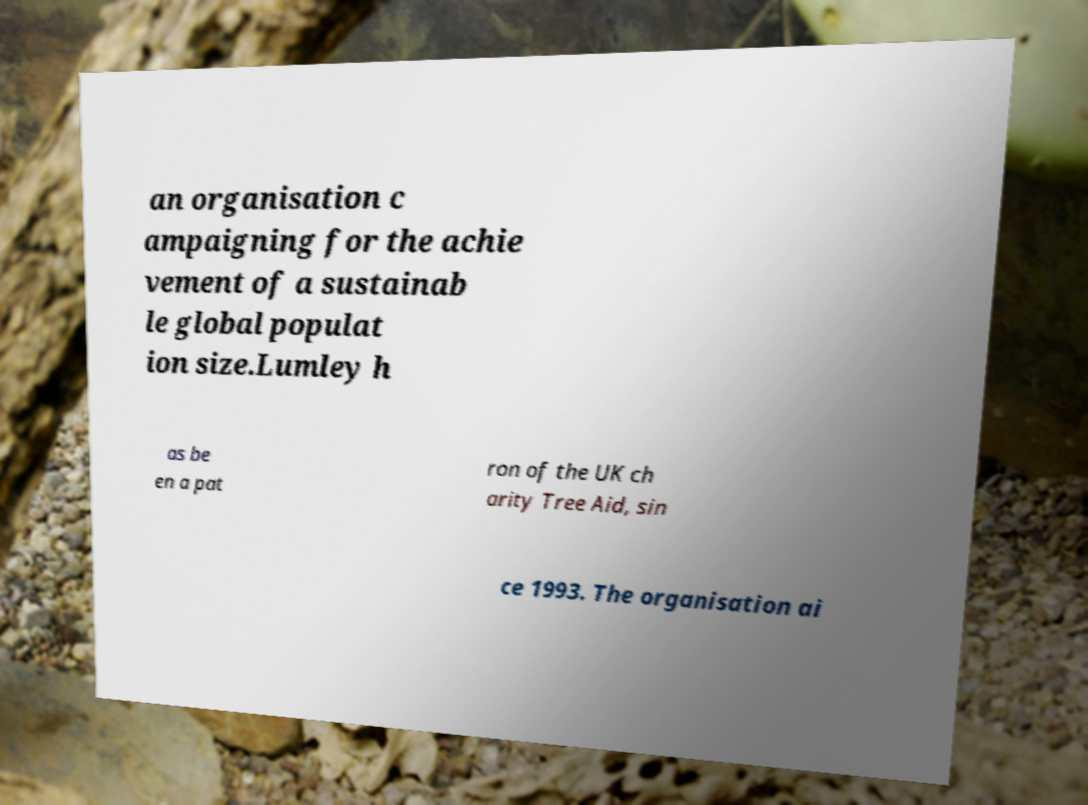For documentation purposes, I need the text within this image transcribed. Could you provide that? an organisation c ampaigning for the achie vement of a sustainab le global populat ion size.Lumley h as be en a pat ron of the UK ch arity Tree Aid, sin ce 1993. The organisation ai 